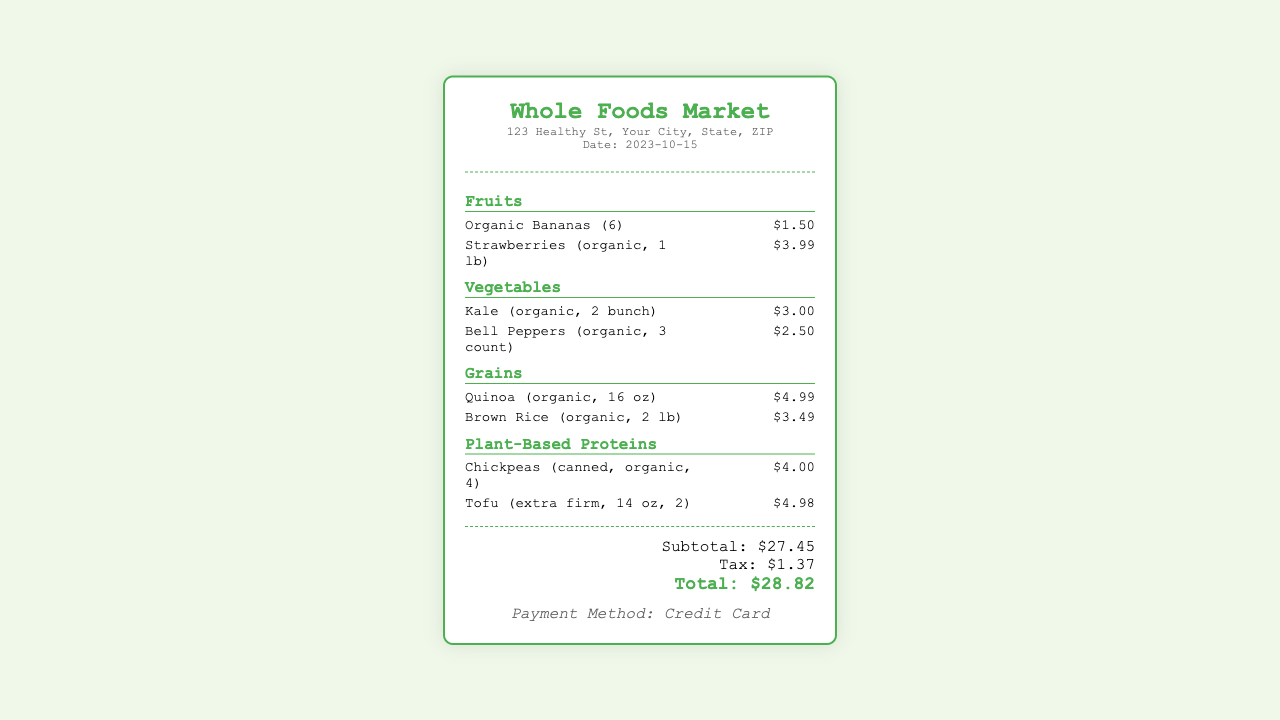what is the date of the grocery purchase? The purchase was made on 2023-10-15 as indicated in the store information section.
Answer: 2023-10-15 how many types of fruits are listed in the receipt? The receipt lists two types of fruits: Organic Bananas and Strawberries (organic).
Answer: 2 what is the price of the Tofu? The price of the Tofu (extra firm, 14 oz, 2) is mentioned in the plant-based proteins section.
Answer: $4.98 how much was spent on vegetables? The total spent on vegetables can be calculated by adding the prices of Kale and Bell Peppers, which is $3.00 + $2.50.
Answer: $5.50 what was the subtotal before tax? The subtotal before tax is provided in the totals section, summing up all item prices.
Answer: $27.45 which store did the grocery shopping take place? The store where the grocery shopping occurred is noted at the top of the receipt.
Answer: Whole Foods Market how many canned Chickpeas were purchased? The number of canned Chickpeas (canned, organic) is specified in the item description on the receipt.
Answer: 4 what payment method was used for this purchase? The payment method for this transaction is mentioned at the bottom of the receipt.
Answer: Credit Card 